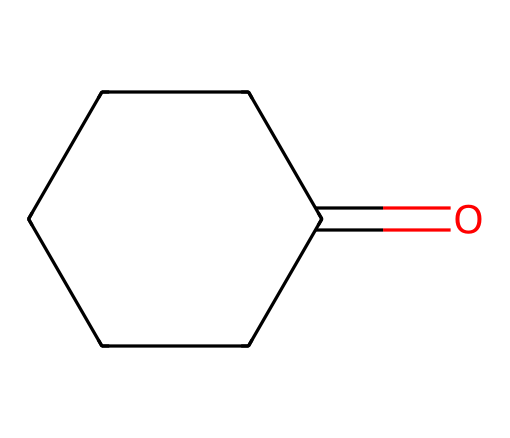What is the name of this chemical? The structure corresponds to a ketone with a six-membered carbon ring and a carbonyl group (C=O). This specific arrangement represents cyclohexanone.
Answer: cyclohexanone How many carbon atoms are present in the structure? By analyzing the SMILES representation, we can count the carbons in the ring (five) plus the carbonyl carbon, totaling six carbon atoms.
Answer: six What functional group is present in cyclohexanone? The presence of the carbonyl group (C=O) in the structure indicates that this molecule features a ketone functional group.
Answer: ketone How many hydrogen atoms are in cyclohexanone? Each carbon in the cyclohexane ring typically has two hydrogen atoms, plus there is one hydrogen on the carbon next to the carbonyl, leading to a total of 10 hydrogen atoms.
Answer: ten Is cyclohexanone a polar or nonpolar solvent? The carbonyl group contributes to some polarity, but the overall structure is relatively nonpolar compared to other solvents due to its cycloalkane nature.
Answer: nonpolar What is the primary use of cyclohexanone in industry? Cyclohexanone is widely used as a solvent in various industrial processes, particularly in the manufacturing of nylon and other synthetic fibers.
Answer: solvent 